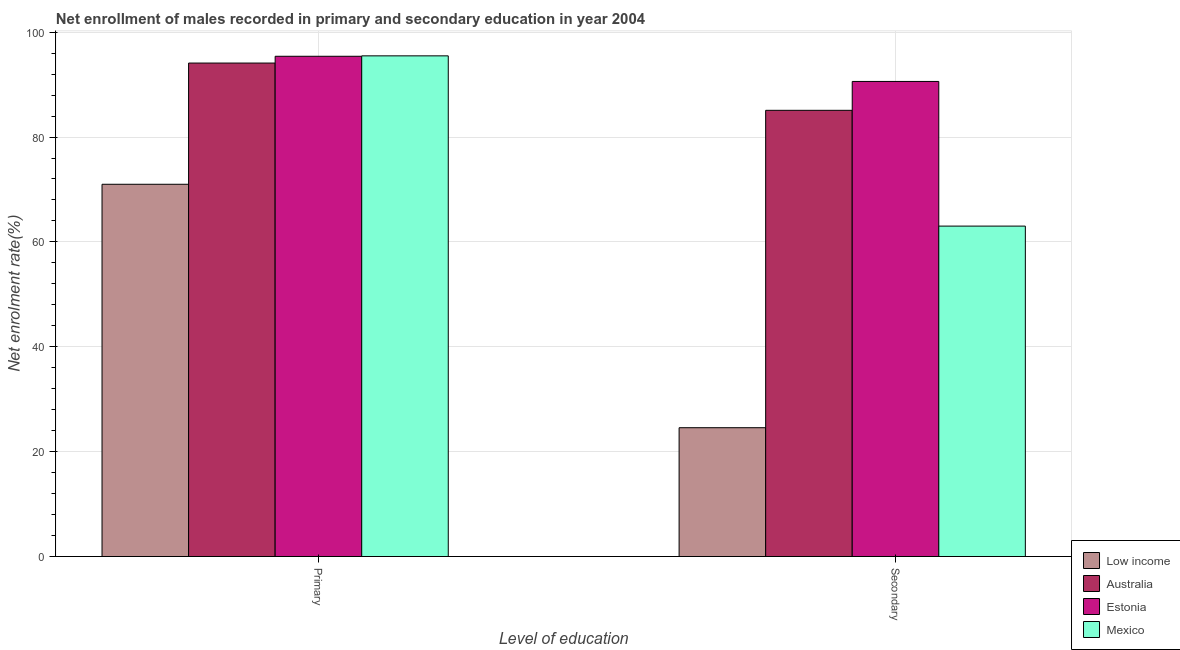How many bars are there on the 1st tick from the right?
Your answer should be very brief. 4. What is the label of the 2nd group of bars from the left?
Provide a succinct answer. Secondary. What is the enrollment rate in secondary education in Estonia?
Offer a terse response. 90.6. Across all countries, what is the maximum enrollment rate in primary education?
Ensure brevity in your answer.  95.48. Across all countries, what is the minimum enrollment rate in primary education?
Provide a short and direct response. 70.99. In which country was the enrollment rate in secondary education maximum?
Your answer should be compact. Estonia. What is the total enrollment rate in secondary education in the graph?
Provide a short and direct response. 263.28. What is the difference between the enrollment rate in secondary education in Estonia and that in Australia?
Make the answer very short. 5.51. What is the difference between the enrollment rate in secondary education in Estonia and the enrollment rate in primary education in Australia?
Keep it short and to the point. -3.51. What is the average enrollment rate in secondary education per country?
Make the answer very short. 65.82. What is the difference between the enrollment rate in secondary education and enrollment rate in primary education in Australia?
Ensure brevity in your answer.  -9.01. What is the ratio of the enrollment rate in secondary education in Estonia to that in Low income?
Your answer should be compact. 3.69. Is the enrollment rate in secondary education in Mexico less than that in Australia?
Offer a very short reply. Yes. What does the 2nd bar from the left in Secondary represents?
Ensure brevity in your answer.  Australia. What does the 1st bar from the right in Secondary represents?
Keep it short and to the point. Mexico. How many bars are there?
Ensure brevity in your answer.  8. Are all the bars in the graph horizontal?
Ensure brevity in your answer.  No. Are the values on the major ticks of Y-axis written in scientific E-notation?
Your answer should be compact. No. Does the graph contain any zero values?
Give a very brief answer. No. Where does the legend appear in the graph?
Offer a very short reply. Bottom right. How many legend labels are there?
Offer a very short reply. 4. How are the legend labels stacked?
Your answer should be very brief. Vertical. What is the title of the graph?
Ensure brevity in your answer.  Net enrollment of males recorded in primary and secondary education in year 2004. What is the label or title of the X-axis?
Provide a short and direct response. Level of education. What is the label or title of the Y-axis?
Keep it short and to the point. Net enrolment rate(%). What is the Net enrolment rate(%) in Low income in Primary?
Provide a succinct answer. 70.99. What is the Net enrolment rate(%) of Australia in Primary?
Make the answer very short. 94.11. What is the Net enrolment rate(%) in Estonia in Primary?
Give a very brief answer. 95.4. What is the Net enrolment rate(%) in Mexico in Primary?
Ensure brevity in your answer.  95.48. What is the Net enrolment rate(%) of Low income in Secondary?
Provide a succinct answer. 24.57. What is the Net enrolment rate(%) of Australia in Secondary?
Provide a succinct answer. 85.1. What is the Net enrolment rate(%) in Estonia in Secondary?
Keep it short and to the point. 90.6. What is the Net enrolment rate(%) in Mexico in Secondary?
Your answer should be very brief. 63.02. Across all Level of education, what is the maximum Net enrolment rate(%) in Low income?
Provide a succinct answer. 70.99. Across all Level of education, what is the maximum Net enrolment rate(%) of Australia?
Ensure brevity in your answer.  94.11. Across all Level of education, what is the maximum Net enrolment rate(%) of Estonia?
Your answer should be compact. 95.4. Across all Level of education, what is the maximum Net enrolment rate(%) in Mexico?
Provide a short and direct response. 95.48. Across all Level of education, what is the minimum Net enrolment rate(%) in Low income?
Offer a very short reply. 24.57. Across all Level of education, what is the minimum Net enrolment rate(%) in Australia?
Your response must be concise. 85.1. Across all Level of education, what is the minimum Net enrolment rate(%) of Estonia?
Make the answer very short. 90.6. Across all Level of education, what is the minimum Net enrolment rate(%) in Mexico?
Ensure brevity in your answer.  63.02. What is the total Net enrolment rate(%) of Low income in the graph?
Your answer should be compact. 95.56. What is the total Net enrolment rate(%) of Australia in the graph?
Offer a terse response. 179.2. What is the total Net enrolment rate(%) in Estonia in the graph?
Keep it short and to the point. 186.01. What is the total Net enrolment rate(%) in Mexico in the graph?
Provide a short and direct response. 158.5. What is the difference between the Net enrolment rate(%) in Low income in Primary and that in Secondary?
Offer a terse response. 46.42. What is the difference between the Net enrolment rate(%) of Australia in Primary and that in Secondary?
Your answer should be compact. 9.01. What is the difference between the Net enrolment rate(%) in Estonia in Primary and that in Secondary?
Provide a short and direct response. 4.8. What is the difference between the Net enrolment rate(%) of Mexico in Primary and that in Secondary?
Keep it short and to the point. 32.47. What is the difference between the Net enrolment rate(%) in Low income in Primary and the Net enrolment rate(%) in Australia in Secondary?
Your response must be concise. -14.1. What is the difference between the Net enrolment rate(%) in Low income in Primary and the Net enrolment rate(%) in Estonia in Secondary?
Ensure brevity in your answer.  -19.61. What is the difference between the Net enrolment rate(%) in Low income in Primary and the Net enrolment rate(%) in Mexico in Secondary?
Offer a terse response. 7.98. What is the difference between the Net enrolment rate(%) of Australia in Primary and the Net enrolment rate(%) of Estonia in Secondary?
Offer a terse response. 3.51. What is the difference between the Net enrolment rate(%) of Australia in Primary and the Net enrolment rate(%) of Mexico in Secondary?
Your response must be concise. 31.09. What is the difference between the Net enrolment rate(%) of Estonia in Primary and the Net enrolment rate(%) of Mexico in Secondary?
Your answer should be compact. 32.39. What is the average Net enrolment rate(%) of Low income per Level of education?
Ensure brevity in your answer.  47.78. What is the average Net enrolment rate(%) of Australia per Level of education?
Provide a succinct answer. 89.6. What is the average Net enrolment rate(%) of Estonia per Level of education?
Ensure brevity in your answer.  93. What is the average Net enrolment rate(%) of Mexico per Level of education?
Your response must be concise. 79.25. What is the difference between the Net enrolment rate(%) in Low income and Net enrolment rate(%) in Australia in Primary?
Offer a terse response. -23.12. What is the difference between the Net enrolment rate(%) in Low income and Net enrolment rate(%) in Estonia in Primary?
Give a very brief answer. -24.41. What is the difference between the Net enrolment rate(%) in Low income and Net enrolment rate(%) in Mexico in Primary?
Give a very brief answer. -24.49. What is the difference between the Net enrolment rate(%) in Australia and Net enrolment rate(%) in Estonia in Primary?
Your answer should be very brief. -1.3. What is the difference between the Net enrolment rate(%) in Australia and Net enrolment rate(%) in Mexico in Primary?
Offer a very short reply. -1.37. What is the difference between the Net enrolment rate(%) of Estonia and Net enrolment rate(%) of Mexico in Primary?
Your answer should be very brief. -0.08. What is the difference between the Net enrolment rate(%) of Low income and Net enrolment rate(%) of Australia in Secondary?
Your answer should be compact. -60.53. What is the difference between the Net enrolment rate(%) of Low income and Net enrolment rate(%) of Estonia in Secondary?
Your response must be concise. -66.03. What is the difference between the Net enrolment rate(%) of Low income and Net enrolment rate(%) of Mexico in Secondary?
Provide a short and direct response. -38.45. What is the difference between the Net enrolment rate(%) in Australia and Net enrolment rate(%) in Estonia in Secondary?
Offer a very short reply. -5.51. What is the difference between the Net enrolment rate(%) of Australia and Net enrolment rate(%) of Mexico in Secondary?
Ensure brevity in your answer.  22.08. What is the difference between the Net enrolment rate(%) of Estonia and Net enrolment rate(%) of Mexico in Secondary?
Your response must be concise. 27.59. What is the ratio of the Net enrolment rate(%) of Low income in Primary to that in Secondary?
Keep it short and to the point. 2.89. What is the ratio of the Net enrolment rate(%) in Australia in Primary to that in Secondary?
Offer a terse response. 1.11. What is the ratio of the Net enrolment rate(%) of Estonia in Primary to that in Secondary?
Make the answer very short. 1.05. What is the ratio of the Net enrolment rate(%) of Mexico in Primary to that in Secondary?
Keep it short and to the point. 1.52. What is the difference between the highest and the second highest Net enrolment rate(%) in Low income?
Ensure brevity in your answer.  46.42. What is the difference between the highest and the second highest Net enrolment rate(%) of Australia?
Make the answer very short. 9.01. What is the difference between the highest and the second highest Net enrolment rate(%) of Estonia?
Give a very brief answer. 4.8. What is the difference between the highest and the second highest Net enrolment rate(%) of Mexico?
Give a very brief answer. 32.47. What is the difference between the highest and the lowest Net enrolment rate(%) of Low income?
Ensure brevity in your answer.  46.42. What is the difference between the highest and the lowest Net enrolment rate(%) in Australia?
Provide a succinct answer. 9.01. What is the difference between the highest and the lowest Net enrolment rate(%) in Estonia?
Ensure brevity in your answer.  4.8. What is the difference between the highest and the lowest Net enrolment rate(%) of Mexico?
Ensure brevity in your answer.  32.47. 